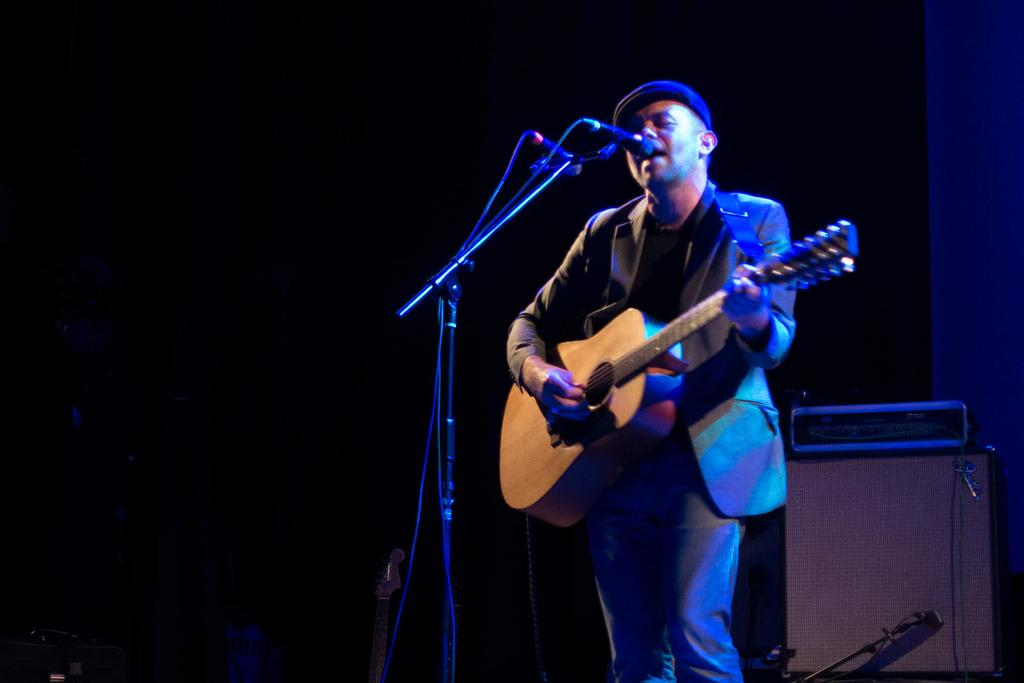What is the main subject of the image? The main subject of the image is a man. What is the man wearing in the image? The man is wearing a suit, hat, and trousers. What is the man doing in the image? The man is playing a guitar. What equipment is present in the image for amplifying sound? There is a microphone and a microphone stand in the image. What can be seen in the background of the image? There is a guitar and a table in the background of the image. Can you tell me how many toads are sitting on the table in the image? There are no toads present in the image; the table in the background has no visible objects on it. 